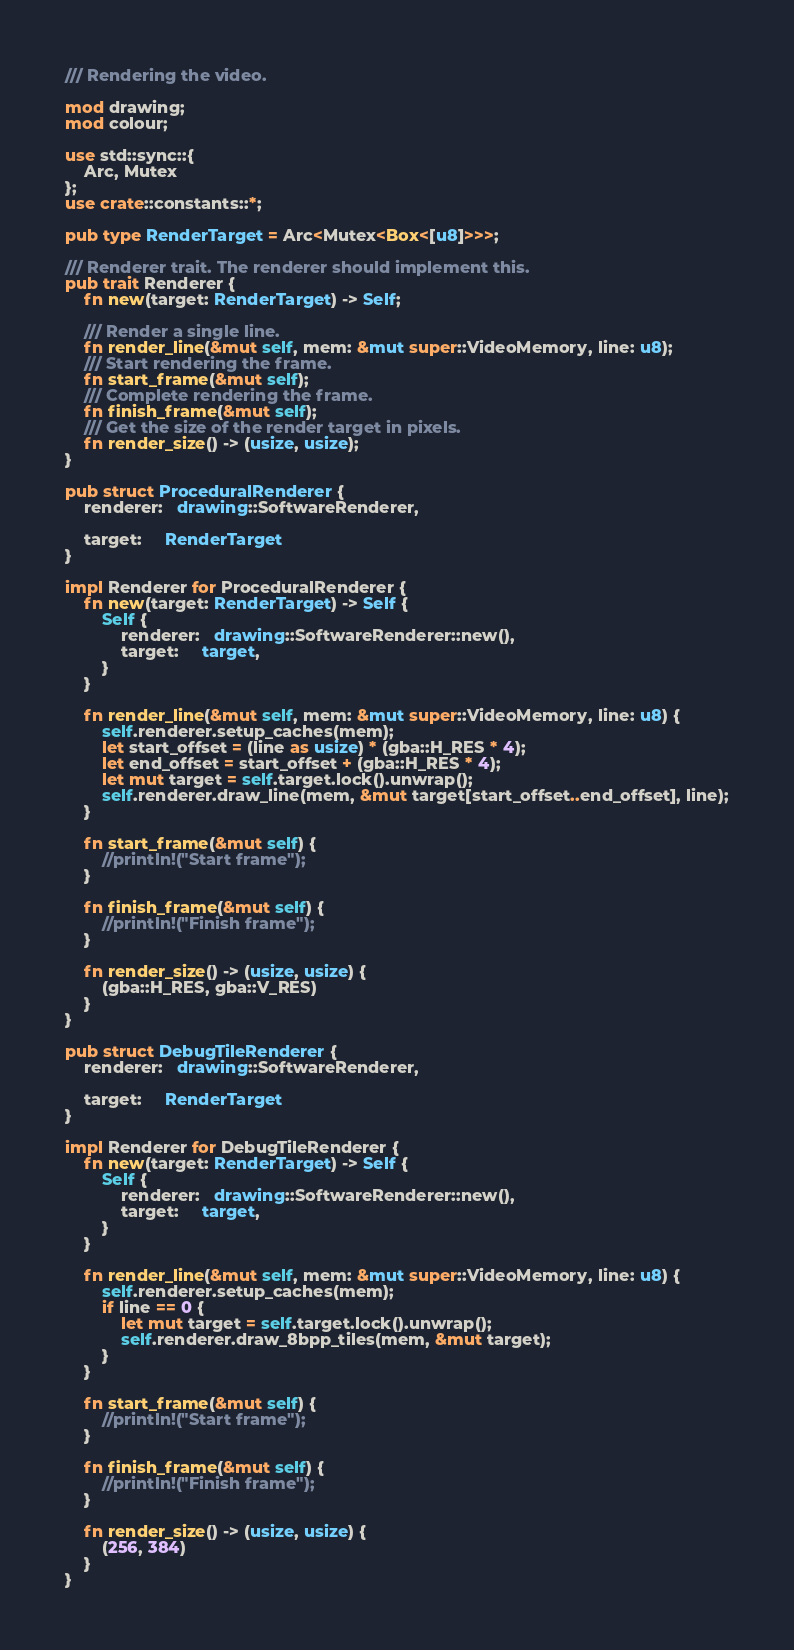Convert code to text. <code><loc_0><loc_0><loc_500><loc_500><_Rust_>/// Rendering the video.

mod drawing;
mod colour;

use std::sync::{
    Arc, Mutex
};
use crate::constants::*;

pub type RenderTarget = Arc<Mutex<Box<[u8]>>>;

/// Renderer trait. The renderer should implement this.
pub trait Renderer {
    fn new(target: RenderTarget) -> Self;

    /// Render a single line.
    fn render_line(&mut self, mem: &mut super::VideoMemory, line: u8);
    /// Start rendering the frame.
    fn start_frame(&mut self);
    /// Complete rendering the frame.
    fn finish_frame(&mut self);
    /// Get the size of the render target in pixels.
    fn render_size() -> (usize, usize);
}

pub struct ProceduralRenderer {
    renderer:   drawing::SoftwareRenderer,

    target:     RenderTarget
}

impl Renderer for ProceduralRenderer {
    fn new(target: RenderTarget) -> Self {
        Self {
            renderer:   drawing::SoftwareRenderer::new(),
            target:     target,
        }
    }

    fn render_line(&mut self, mem: &mut super::VideoMemory, line: u8) {
        self.renderer.setup_caches(mem);
        let start_offset = (line as usize) * (gba::H_RES * 4);
        let end_offset = start_offset + (gba::H_RES * 4);
        let mut target = self.target.lock().unwrap();
        self.renderer.draw_line(mem, &mut target[start_offset..end_offset], line);
    }

    fn start_frame(&mut self) {
        //println!("Start frame");
    }

    fn finish_frame(&mut self) {
        //println!("Finish frame");
    }

    fn render_size() -> (usize, usize) {
        (gba::H_RES, gba::V_RES)
    }
}

pub struct DebugTileRenderer {
    renderer:   drawing::SoftwareRenderer,

    target:     RenderTarget
}

impl Renderer for DebugTileRenderer {
    fn new(target: RenderTarget) -> Self {
        Self {
            renderer:   drawing::SoftwareRenderer::new(),
            target:     target,
        }
    }

    fn render_line(&mut self, mem: &mut super::VideoMemory, line: u8) {
        self.renderer.setup_caches(mem);
        if line == 0 {
            let mut target = self.target.lock().unwrap();
            self.renderer.draw_8bpp_tiles(mem, &mut target);
        }
    }

    fn start_frame(&mut self) {
        //println!("Start frame");
    }

    fn finish_frame(&mut self) {
        //println!("Finish frame");
    }

    fn render_size() -> (usize, usize) {
        (256, 384)
    }
}
</code> 